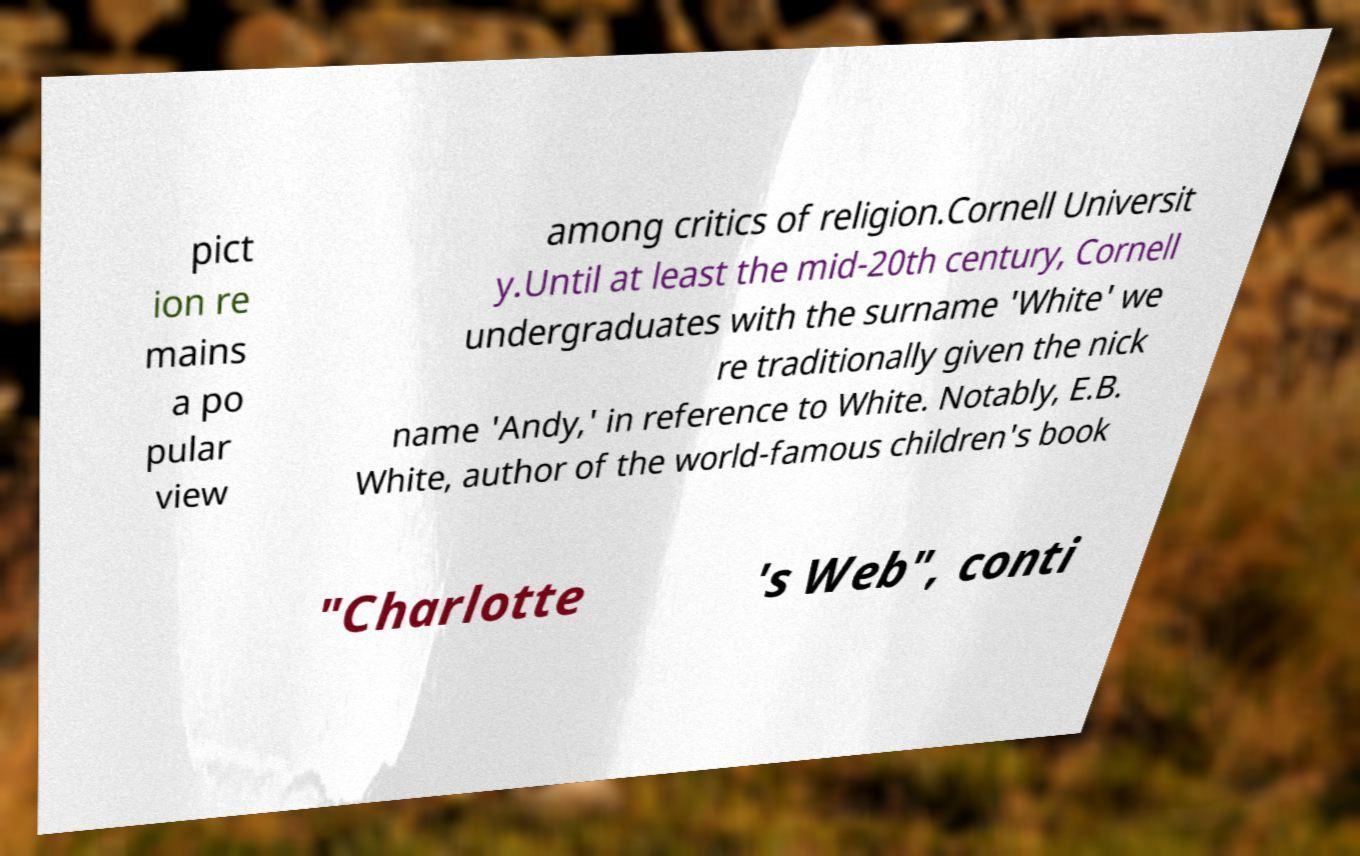Please read and relay the text visible in this image. What does it say? pict ion re mains a po pular view among critics of religion.Cornell Universit y.Until at least the mid-20th century, Cornell undergraduates with the surname 'White' we re traditionally given the nick name 'Andy,' in reference to White. Notably, E.B. White, author of the world-famous children's book "Charlotte 's Web", conti 